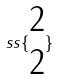<formula> <loc_0><loc_0><loc_500><loc_500>s s \{ \begin{matrix} 2 \\ 2 \end{matrix} \}</formula> 